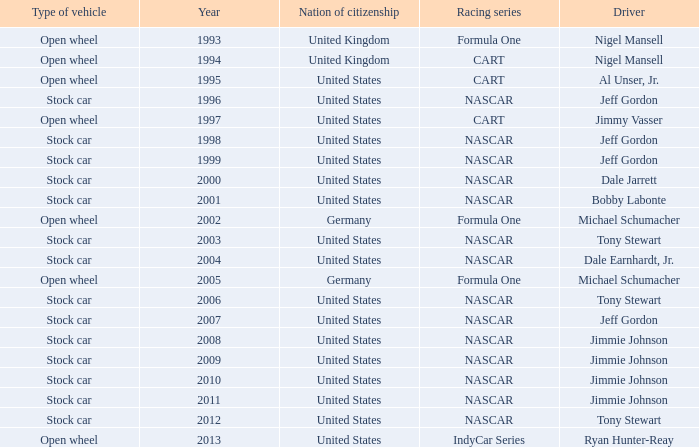What driver has a stock car vehicle with a year of 1999? Jeff Gordon. 